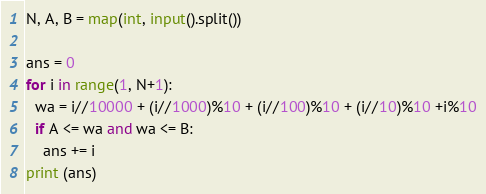<code> <loc_0><loc_0><loc_500><loc_500><_Python_>N, A, B = map(int, input().split())

ans = 0
for i in range(1, N+1):
  wa = i//10000 + (i//1000)%10 + (i//100)%10 + (i//10)%10 +i%10
  if A <= wa and wa <= B:
    ans += i
print (ans)</code> 